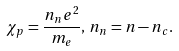Convert formula to latex. <formula><loc_0><loc_0><loc_500><loc_500>\chi _ { p } = \frac { n _ { n } e ^ { 2 } } { m _ { e } } , \, n _ { n } = n - n _ { c } .</formula> 